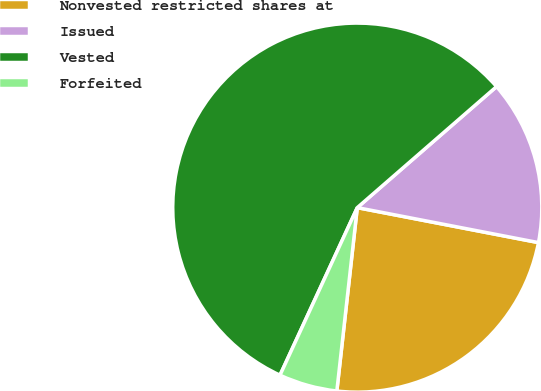Convert chart. <chart><loc_0><loc_0><loc_500><loc_500><pie_chart><fcel>Nonvested restricted shares at<fcel>Issued<fcel>Vested<fcel>Forfeited<nl><fcel>23.73%<fcel>14.42%<fcel>56.73%<fcel>5.11%<nl></chart> 